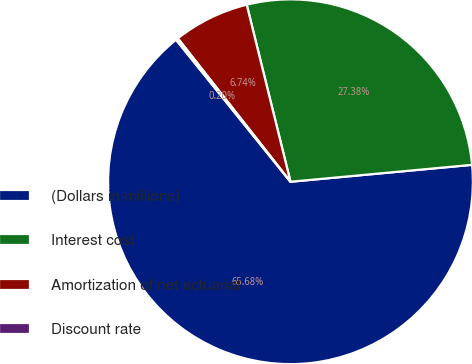Convert chart. <chart><loc_0><loc_0><loc_500><loc_500><pie_chart><fcel>(Dollars in millions)<fcel>Interest cost<fcel>Amortization of net actuarial<fcel>Discount rate<nl><fcel>65.68%<fcel>27.38%<fcel>6.74%<fcel>0.2%<nl></chart> 